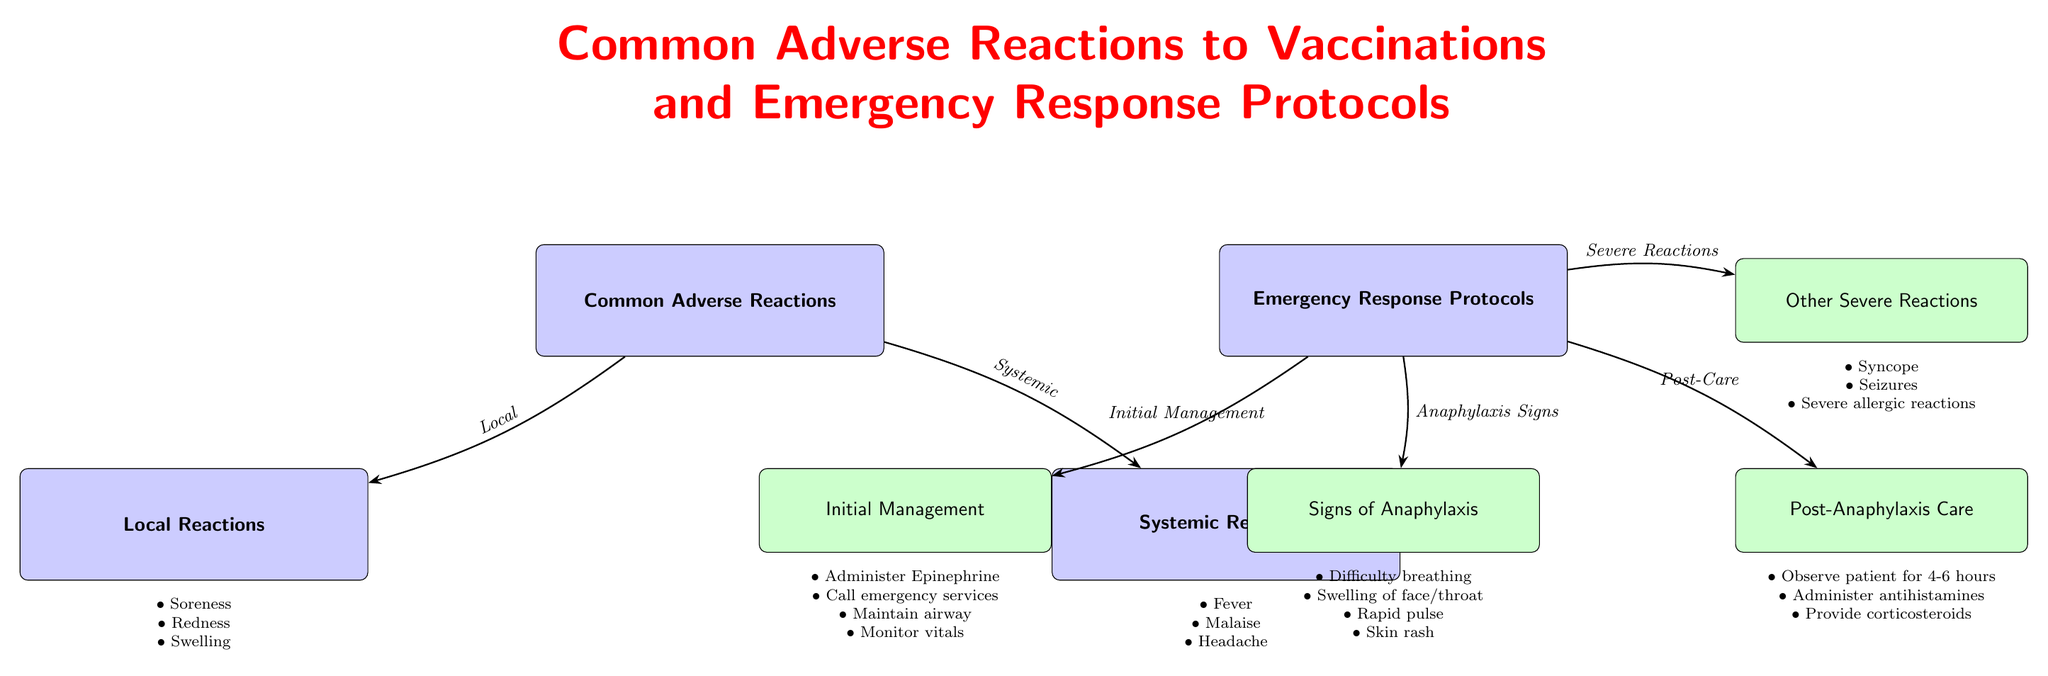What are some examples of local reactions? The diagram lists three specific examples of local reactions directly under the "Local Reactions" node: soreness, redness, and swelling.
Answer: Soreness, redness, swelling What is the first step in the initial management of anaphylaxis? The "Initial Management" node specifies that the first action is to "Administer Epinephrine." This indicates the critical first step in an emergency response to anaphylaxis.
Answer: Administer Epinephrine How many systemic reactions are listed in the diagram? There are three specific systemic reactions mentioned under the "Systemic Reactions" node: fever, malaise, and headache. Counting these gives a total of three systemic reactions.
Answer: 3 What reactions fall under the "Other Severe Reactions" category? The diagram provides three examples under "Other Severe Reactions": syncope, seizures, and severe allergic reactions. These are directly listed in that section.
Answer: Syncope, seizures, severe allergic reactions What should be done after anaphylaxis has occurred, according to the diagram? The "Post-Anaphylaxis Care" section outlines three actions to take after a patient has experienced anaphylaxis: observe patient for 4-6 hours, administer antihistamines, and provide corticosteroids.
Answer: Observe patient for 4-6 hours, administer antihistamines, provide corticosteroids What connects "Common Adverse Reactions" to "Local Reactions"? The diagram specifically indicates a connection labeled "Local" which shows the relationship between these two nodes, associating local reactions as a category of common adverse reactions.
Answer: Local What signs are indicative of anaphylaxis? The "Signs of Anaphylaxis" node lists four signs: difficulty breathing, swelling of face/throat, rapid pulse, and skin rash, indicating key symptoms to recognize anaphylaxis.
Answer: Difficulty breathing, swelling of face/throat, rapid pulse, skin rash Which node provides details about managing severe reactions? The "Emergency Response Protocols" node includes a direct connection to the "Other Severe Reactions" node, indicating that this part of the diagram focuses on managing severe reactions in addition to anaphylaxis.
Answer: Other Severe Reactions 